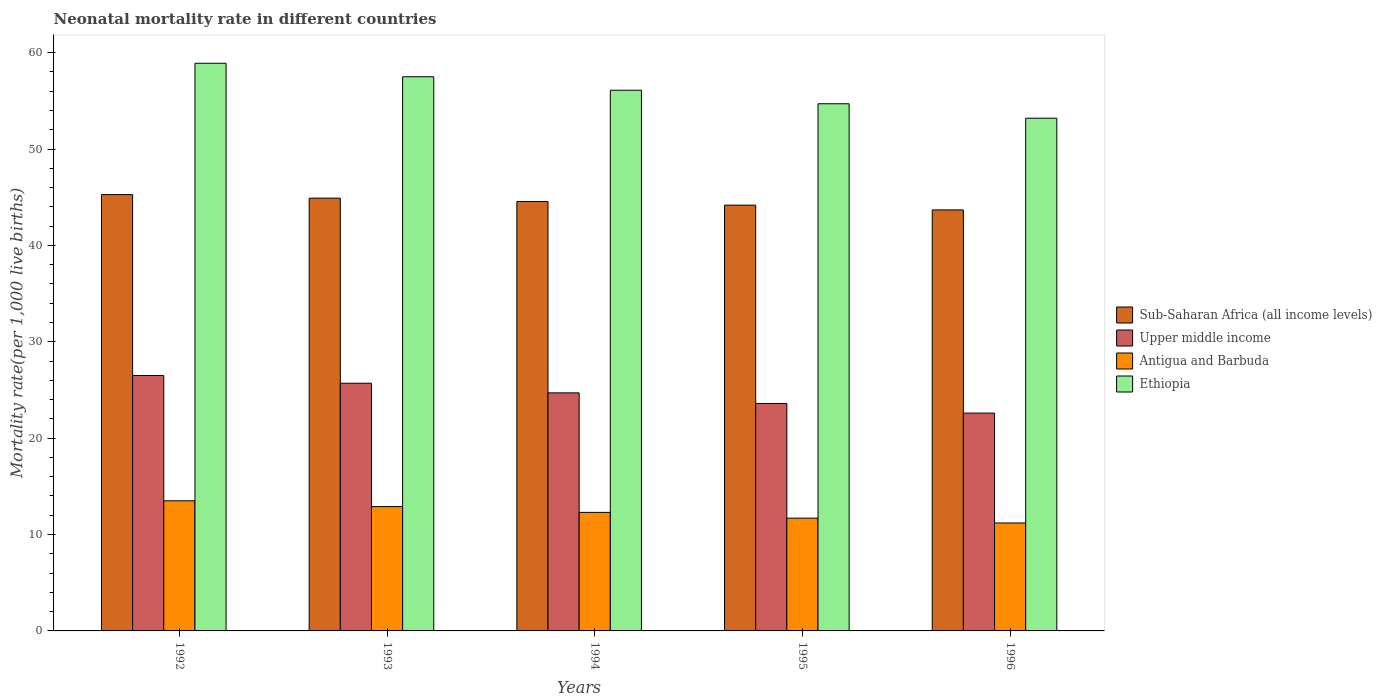How many bars are there on the 4th tick from the left?
Keep it short and to the point. 4. What is the label of the 2nd group of bars from the left?
Provide a short and direct response. 1993. Across all years, what is the maximum neonatal mortality rate in Antigua and Barbuda?
Ensure brevity in your answer.  13.5. In which year was the neonatal mortality rate in Sub-Saharan Africa (all income levels) minimum?
Provide a short and direct response. 1996. What is the total neonatal mortality rate in Upper middle income in the graph?
Offer a terse response. 123.1. What is the difference between the neonatal mortality rate in Ethiopia in 1993 and that in 1995?
Your answer should be very brief. 2.8. What is the difference between the neonatal mortality rate in Sub-Saharan Africa (all income levels) in 1996 and the neonatal mortality rate in Ethiopia in 1995?
Make the answer very short. -11.02. What is the average neonatal mortality rate in Antigua and Barbuda per year?
Make the answer very short. 12.32. In the year 1996, what is the difference between the neonatal mortality rate in Upper middle income and neonatal mortality rate in Sub-Saharan Africa (all income levels)?
Your answer should be compact. -21.08. What is the ratio of the neonatal mortality rate in Upper middle income in 1995 to that in 1996?
Provide a succinct answer. 1.04. Is the difference between the neonatal mortality rate in Upper middle income in 1994 and 1996 greater than the difference between the neonatal mortality rate in Sub-Saharan Africa (all income levels) in 1994 and 1996?
Your response must be concise. Yes. What is the difference between the highest and the second highest neonatal mortality rate in Ethiopia?
Make the answer very short. 1.4. What is the difference between the highest and the lowest neonatal mortality rate in Sub-Saharan Africa (all income levels)?
Keep it short and to the point. 1.59. In how many years, is the neonatal mortality rate in Antigua and Barbuda greater than the average neonatal mortality rate in Antigua and Barbuda taken over all years?
Your answer should be very brief. 2. Is it the case that in every year, the sum of the neonatal mortality rate in Upper middle income and neonatal mortality rate in Ethiopia is greater than the sum of neonatal mortality rate in Sub-Saharan Africa (all income levels) and neonatal mortality rate in Antigua and Barbuda?
Keep it short and to the point. No. What does the 1st bar from the left in 1993 represents?
Your response must be concise. Sub-Saharan Africa (all income levels). What does the 3rd bar from the right in 1992 represents?
Ensure brevity in your answer.  Upper middle income. Is it the case that in every year, the sum of the neonatal mortality rate in Antigua and Barbuda and neonatal mortality rate in Sub-Saharan Africa (all income levels) is greater than the neonatal mortality rate in Ethiopia?
Give a very brief answer. No. How many bars are there?
Ensure brevity in your answer.  20. Are all the bars in the graph horizontal?
Offer a terse response. No. What is the difference between two consecutive major ticks on the Y-axis?
Provide a short and direct response. 10. Are the values on the major ticks of Y-axis written in scientific E-notation?
Make the answer very short. No. Does the graph contain grids?
Provide a succinct answer. No. Where does the legend appear in the graph?
Keep it short and to the point. Center right. How are the legend labels stacked?
Your response must be concise. Vertical. What is the title of the graph?
Your response must be concise. Neonatal mortality rate in different countries. What is the label or title of the X-axis?
Keep it short and to the point. Years. What is the label or title of the Y-axis?
Provide a short and direct response. Mortality rate(per 1,0 live births). What is the Mortality rate(per 1,000 live births) in Sub-Saharan Africa (all income levels) in 1992?
Offer a very short reply. 45.27. What is the Mortality rate(per 1,000 live births) in Ethiopia in 1992?
Provide a succinct answer. 58.9. What is the Mortality rate(per 1,000 live births) of Sub-Saharan Africa (all income levels) in 1993?
Your answer should be very brief. 44.91. What is the Mortality rate(per 1,000 live births) in Upper middle income in 1993?
Ensure brevity in your answer.  25.7. What is the Mortality rate(per 1,000 live births) in Antigua and Barbuda in 1993?
Your answer should be compact. 12.9. What is the Mortality rate(per 1,000 live births) of Ethiopia in 1993?
Your answer should be compact. 57.5. What is the Mortality rate(per 1,000 live births) in Sub-Saharan Africa (all income levels) in 1994?
Make the answer very short. 44.55. What is the Mortality rate(per 1,000 live births) of Upper middle income in 1994?
Keep it short and to the point. 24.7. What is the Mortality rate(per 1,000 live births) of Antigua and Barbuda in 1994?
Ensure brevity in your answer.  12.3. What is the Mortality rate(per 1,000 live births) in Ethiopia in 1994?
Offer a very short reply. 56.1. What is the Mortality rate(per 1,000 live births) in Sub-Saharan Africa (all income levels) in 1995?
Your answer should be very brief. 44.18. What is the Mortality rate(per 1,000 live births) of Upper middle income in 1995?
Ensure brevity in your answer.  23.6. What is the Mortality rate(per 1,000 live births) of Antigua and Barbuda in 1995?
Ensure brevity in your answer.  11.7. What is the Mortality rate(per 1,000 live births) in Ethiopia in 1995?
Make the answer very short. 54.7. What is the Mortality rate(per 1,000 live births) in Sub-Saharan Africa (all income levels) in 1996?
Offer a terse response. 43.68. What is the Mortality rate(per 1,000 live births) in Upper middle income in 1996?
Offer a very short reply. 22.6. What is the Mortality rate(per 1,000 live births) of Antigua and Barbuda in 1996?
Offer a terse response. 11.2. What is the Mortality rate(per 1,000 live births) in Ethiopia in 1996?
Give a very brief answer. 53.2. Across all years, what is the maximum Mortality rate(per 1,000 live births) of Sub-Saharan Africa (all income levels)?
Your response must be concise. 45.27. Across all years, what is the maximum Mortality rate(per 1,000 live births) of Upper middle income?
Give a very brief answer. 26.5. Across all years, what is the maximum Mortality rate(per 1,000 live births) in Antigua and Barbuda?
Your answer should be compact. 13.5. Across all years, what is the maximum Mortality rate(per 1,000 live births) in Ethiopia?
Offer a terse response. 58.9. Across all years, what is the minimum Mortality rate(per 1,000 live births) of Sub-Saharan Africa (all income levels)?
Offer a very short reply. 43.68. Across all years, what is the minimum Mortality rate(per 1,000 live births) in Upper middle income?
Make the answer very short. 22.6. Across all years, what is the minimum Mortality rate(per 1,000 live births) in Ethiopia?
Give a very brief answer. 53.2. What is the total Mortality rate(per 1,000 live births) in Sub-Saharan Africa (all income levels) in the graph?
Offer a terse response. 222.59. What is the total Mortality rate(per 1,000 live births) in Upper middle income in the graph?
Offer a very short reply. 123.1. What is the total Mortality rate(per 1,000 live births) in Antigua and Barbuda in the graph?
Offer a very short reply. 61.6. What is the total Mortality rate(per 1,000 live births) of Ethiopia in the graph?
Your answer should be compact. 280.4. What is the difference between the Mortality rate(per 1,000 live births) in Sub-Saharan Africa (all income levels) in 1992 and that in 1993?
Give a very brief answer. 0.37. What is the difference between the Mortality rate(per 1,000 live births) of Upper middle income in 1992 and that in 1993?
Your response must be concise. 0.8. What is the difference between the Mortality rate(per 1,000 live births) in Antigua and Barbuda in 1992 and that in 1993?
Provide a short and direct response. 0.6. What is the difference between the Mortality rate(per 1,000 live births) of Ethiopia in 1992 and that in 1993?
Ensure brevity in your answer.  1.4. What is the difference between the Mortality rate(per 1,000 live births) in Sub-Saharan Africa (all income levels) in 1992 and that in 1994?
Make the answer very short. 0.72. What is the difference between the Mortality rate(per 1,000 live births) in Antigua and Barbuda in 1992 and that in 1994?
Provide a short and direct response. 1.2. What is the difference between the Mortality rate(per 1,000 live births) in Ethiopia in 1992 and that in 1994?
Your answer should be very brief. 2.8. What is the difference between the Mortality rate(per 1,000 live births) of Sub-Saharan Africa (all income levels) in 1992 and that in 1995?
Your answer should be very brief. 1.09. What is the difference between the Mortality rate(per 1,000 live births) of Upper middle income in 1992 and that in 1995?
Provide a succinct answer. 2.9. What is the difference between the Mortality rate(per 1,000 live births) of Antigua and Barbuda in 1992 and that in 1995?
Offer a very short reply. 1.8. What is the difference between the Mortality rate(per 1,000 live births) of Sub-Saharan Africa (all income levels) in 1992 and that in 1996?
Give a very brief answer. 1.59. What is the difference between the Mortality rate(per 1,000 live births) in Upper middle income in 1992 and that in 1996?
Provide a short and direct response. 3.9. What is the difference between the Mortality rate(per 1,000 live births) of Sub-Saharan Africa (all income levels) in 1993 and that in 1994?
Offer a terse response. 0.35. What is the difference between the Mortality rate(per 1,000 live births) in Upper middle income in 1993 and that in 1994?
Your answer should be compact. 1. What is the difference between the Mortality rate(per 1,000 live births) in Antigua and Barbuda in 1993 and that in 1994?
Make the answer very short. 0.6. What is the difference between the Mortality rate(per 1,000 live births) of Ethiopia in 1993 and that in 1994?
Offer a very short reply. 1.4. What is the difference between the Mortality rate(per 1,000 live births) in Sub-Saharan Africa (all income levels) in 1993 and that in 1995?
Offer a very short reply. 0.73. What is the difference between the Mortality rate(per 1,000 live births) in Upper middle income in 1993 and that in 1995?
Give a very brief answer. 2.1. What is the difference between the Mortality rate(per 1,000 live births) of Ethiopia in 1993 and that in 1995?
Give a very brief answer. 2.8. What is the difference between the Mortality rate(per 1,000 live births) of Sub-Saharan Africa (all income levels) in 1993 and that in 1996?
Your response must be concise. 1.22. What is the difference between the Mortality rate(per 1,000 live births) of Upper middle income in 1993 and that in 1996?
Make the answer very short. 3.1. What is the difference between the Mortality rate(per 1,000 live births) in Sub-Saharan Africa (all income levels) in 1994 and that in 1995?
Give a very brief answer. 0.37. What is the difference between the Mortality rate(per 1,000 live births) in Sub-Saharan Africa (all income levels) in 1994 and that in 1996?
Offer a very short reply. 0.87. What is the difference between the Mortality rate(per 1,000 live births) in Ethiopia in 1994 and that in 1996?
Keep it short and to the point. 2.9. What is the difference between the Mortality rate(per 1,000 live births) of Sub-Saharan Africa (all income levels) in 1995 and that in 1996?
Provide a short and direct response. 0.5. What is the difference between the Mortality rate(per 1,000 live births) of Upper middle income in 1995 and that in 1996?
Offer a very short reply. 1. What is the difference between the Mortality rate(per 1,000 live births) in Ethiopia in 1995 and that in 1996?
Keep it short and to the point. 1.5. What is the difference between the Mortality rate(per 1,000 live births) of Sub-Saharan Africa (all income levels) in 1992 and the Mortality rate(per 1,000 live births) of Upper middle income in 1993?
Provide a succinct answer. 19.57. What is the difference between the Mortality rate(per 1,000 live births) of Sub-Saharan Africa (all income levels) in 1992 and the Mortality rate(per 1,000 live births) of Antigua and Barbuda in 1993?
Provide a short and direct response. 32.37. What is the difference between the Mortality rate(per 1,000 live births) of Sub-Saharan Africa (all income levels) in 1992 and the Mortality rate(per 1,000 live births) of Ethiopia in 1993?
Ensure brevity in your answer.  -12.23. What is the difference between the Mortality rate(per 1,000 live births) in Upper middle income in 1992 and the Mortality rate(per 1,000 live births) in Ethiopia in 1993?
Your answer should be very brief. -31. What is the difference between the Mortality rate(per 1,000 live births) in Antigua and Barbuda in 1992 and the Mortality rate(per 1,000 live births) in Ethiopia in 1993?
Your answer should be compact. -44. What is the difference between the Mortality rate(per 1,000 live births) in Sub-Saharan Africa (all income levels) in 1992 and the Mortality rate(per 1,000 live births) in Upper middle income in 1994?
Keep it short and to the point. 20.57. What is the difference between the Mortality rate(per 1,000 live births) of Sub-Saharan Africa (all income levels) in 1992 and the Mortality rate(per 1,000 live births) of Antigua and Barbuda in 1994?
Offer a terse response. 32.97. What is the difference between the Mortality rate(per 1,000 live births) in Sub-Saharan Africa (all income levels) in 1992 and the Mortality rate(per 1,000 live births) in Ethiopia in 1994?
Keep it short and to the point. -10.83. What is the difference between the Mortality rate(per 1,000 live births) in Upper middle income in 1992 and the Mortality rate(per 1,000 live births) in Ethiopia in 1994?
Make the answer very short. -29.6. What is the difference between the Mortality rate(per 1,000 live births) of Antigua and Barbuda in 1992 and the Mortality rate(per 1,000 live births) of Ethiopia in 1994?
Make the answer very short. -42.6. What is the difference between the Mortality rate(per 1,000 live births) in Sub-Saharan Africa (all income levels) in 1992 and the Mortality rate(per 1,000 live births) in Upper middle income in 1995?
Ensure brevity in your answer.  21.67. What is the difference between the Mortality rate(per 1,000 live births) of Sub-Saharan Africa (all income levels) in 1992 and the Mortality rate(per 1,000 live births) of Antigua and Barbuda in 1995?
Provide a short and direct response. 33.57. What is the difference between the Mortality rate(per 1,000 live births) of Sub-Saharan Africa (all income levels) in 1992 and the Mortality rate(per 1,000 live births) of Ethiopia in 1995?
Ensure brevity in your answer.  -9.43. What is the difference between the Mortality rate(per 1,000 live births) in Upper middle income in 1992 and the Mortality rate(per 1,000 live births) in Ethiopia in 1995?
Your response must be concise. -28.2. What is the difference between the Mortality rate(per 1,000 live births) of Antigua and Barbuda in 1992 and the Mortality rate(per 1,000 live births) of Ethiopia in 1995?
Ensure brevity in your answer.  -41.2. What is the difference between the Mortality rate(per 1,000 live births) in Sub-Saharan Africa (all income levels) in 1992 and the Mortality rate(per 1,000 live births) in Upper middle income in 1996?
Make the answer very short. 22.67. What is the difference between the Mortality rate(per 1,000 live births) in Sub-Saharan Africa (all income levels) in 1992 and the Mortality rate(per 1,000 live births) in Antigua and Barbuda in 1996?
Keep it short and to the point. 34.07. What is the difference between the Mortality rate(per 1,000 live births) in Sub-Saharan Africa (all income levels) in 1992 and the Mortality rate(per 1,000 live births) in Ethiopia in 1996?
Offer a terse response. -7.93. What is the difference between the Mortality rate(per 1,000 live births) of Upper middle income in 1992 and the Mortality rate(per 1,000 live births) of Antigua and Barbuda in 1996?
Offer a very short reply. 15.3. What is the difference between the Mortality rate(per 1,000 live births) in Upper middle income in 1992 and the Mortality rate(per 1,000 live births) in Ethiopia in 1996?
Keep it short and to the point. -26.7. What is the difference between the Mortality rate(per 1,000 live births) in Antigua and Barbuda in 1992 and the Mortality rate(per 1,000 live births) in Ethiopia in 1996?
Provide a succinct answer. -39.7. What is the difference between the Mortality rate(per 1,000 live births) of Sub-Saharan Africa (all income levels) in 1993 and the Mortality rate(per 1,000 live births) of Upper middle income in 1994?
Provide a short and direct response. 20.21. What is the difference between the Mortality rate(per 1,000 live births) in Sub-Saharan Africa (all income levels) in 1993 and the Mortality rate(per 1,000 live births) in Antigua and Barbuda in 1994?
Give a very brief answer. 32.61. What is the difference between the Mortality rate(per 1,000 live births) of Sub-Saharan Africa (all income levels) in 1993 and the Mortality rate(per 1,000 live births) of Ethiopia in 1994?
Your answer should be very brief. -11.19. What is the difference between the Mortality rate(per 1,000 live births) in Upper middle income in 1993 and the Mortality rate(per 1,000 live births) in Ethiopia in 1994?
Provide a succinct answer. -30.4. What is the difference between the Mortality rate(per 1,000 live births) of Antigua and Barbuda in 1993 and the Mortality rate(per 1,000 live births) of Ethiopia in 1994?
Provide a short and direct response. -43.2. What is the difference between the Mortality rate(per 1,000 live births) of Sub-Saharan Africa (all income levels) in 1993 and the Mortality rate(per 1,000 live births) of Upper middle income in 1995?
Offer a very short reply. 21.31. What is the difference between the Mortality rate(per 1,000 live births) of Sub-Saharan Africa (all income levels) in 1993 and the Mortality rate(per 1,000 live births) of Antigua and Barbuda in 1995?
Give a very brief answer. 33.21. What is the difference between the Mortality rate(per 1,000 live births) of Sub-Saharan Africa (all income levels) in 1993 and the Mortality rate(per 1,000 live births) of Ethiopia in 1995?
Offer a terse response. -9.79. What is the difference between the Mortality rate(per 1,000 live births) of Upper middle income in 1993 and the Mortality rate(per 1,000 live births) of Antigua and Barbuda in 1995?
Ensure brevity in your answer.  14. What is the difference between the Mortality rate(per 1,000 live births) in Upper middle income in 1993 and the Mortality rate(per 1,000 live births) in Ethiopia in 1995?
Offer a very short reply. -29. What is the difference between the Mortality rate(per 1,000 live births) in Antigua and Barbuda in 1993 and the Mortality rate(per 1,000 live births) in Ethiopia in 1995?
Provide a short and direct response. -41.8. What is the difference between the Mortality rate(per 1,000 live births) in Sub-Saharan Africa (all income levels) in 1993 and the Mortality rate(per 1,000 live births) in Upper middle income in 1996?
Give a very brief answer. 22.31. What is the difference between the Mortality rate(per 1,000 live births) of Sub-Saharan Africa (all income levels) in 1993 and the Mortality rate(per 1,000 live births) of Antigua and Barbuda in 1996?
Your answer should be very brief. 33.71. What is the difference between the Mortality rate(per 1,000 live births) in Sub-Saharan Africa (all income levels) in 1993 and the Mortality rate(per 1,000 live births) in Ethiopia in 1996?
Provide a succinct answer. -8.29. What is the difference between the Mortality rate(per 1,000 live births) in Upper middle income in 1993 and the Mortality rate(per 1,000 live births) in Ethiopia in 1996?
Your answer should be compact. -27.5. What is the difference between the Mortality rate(per 1,000 live births) in Antigua and Barbuda in 1993 and the Mortality rate(per 1,000 live births) in Ethiopia in 1996?
Make the answer very short. -40.3. What is the difference between the Mortality rate(per 1,000 live births) of Sub-Saharan Africa (all income levels) in 1994 and the Mortality rate(per 1,000 live births) of Upper middle income in 1995?
Your answer should be compact. 20.95. What is the difference between the Mortality rate(per 1,000 live births) in Sub-Saharan Africa (all income levels) in 1994 and the Mortality rate(per 1,000 live births) in Antigua and Barbuda in 1995?
Offer a very short reply. 32.85. What is the difference between the Mortality rate(per 1,000 live births) of Sub-Saharan Africa (all income levels) in 1994 and the Mortality rate(per 1,000 live births) of Ethiopia in 1995?
Provide a succinct answer. -10.15. What is the difference between the Mortality rate(per 1,000 live births) of Antigua and Barbuda in 1994 and the Mortality rate(per 1,000 live births) of Ethiopia in 1995?
Offer a very short reply. -42.4. What is the difference between the Mortality rate(per 1,000 live births) in Sub-Saharan Africa (all income levels) in 1994 and the Mortality rate(per 1,000 live births) in Upper middle income in 1996?
Give a very brief answer. 21.95. What is the difference between the Mortality rate(per 1,000 live births) in Sub-Saharan Africa (all income levels) in 1994 and the Mortality rate(per 1,000 live births) in Antigua and Barbuda in 1996?
Your answer should be compact. 33.35. What is the difference between the Mortality rate(per 1,000 live births) of Sub-Saharan Africa (all income levels) in 1994 and the Mortality rate(per 1,000 live births) of Ethiopia in 1996?
Your answer should be compact. -8.65. What is the difference between the Mortality rate(per 1,000 live births) in Upper middle income in 1994 and the Mortality rate(per 1,000 live births) in Ethiopia in 1996?
Provide a succinct answer. -28.5. What is the difference between the Mortality rate(per 1,000 live births) of Antigua and Barbuda in 1994 and the Mortality rate(per 1,000 live births) of Ethiopia in 1996?
Your answer should be very brief. -40.9. What is the difference between the Mortality rate(per 1,000 live births) of Sub-Saharan Africa (all income levels) in 1995 and the Mortality rate(per 1,000 live births) of Upper middle income in 1996?
Give a very brief answer. 21.58. What is the difference between the Mortality rate(per 1,000 live births) of Sub-Saharan Africa (all income levels) in 1995 and the Mortality rate(per 1,000 live births) of Antigua and Barbuda in 1996?
Ensure brevity in your answer.  32.98. What is the difference between the Mortality rate(per 1,000 live births) in Sub-Saharan Africa (all income levels) in 1995 and the Mortality rate(per 1,000 live births) in Ethiopia in 1996?
Your answer should be very brief. -9.02. What is the difference between the Mortality rate(per 1,000 live births) of Upper middle income in 1995 and the Mortality rate(per 1,000 live births) of Ethiopia in 1996?
Give a very brief answer. -29.6. What is the difference between the Mortality rate(per 1,000 live births) in Antigua and Barbuda in 1995 and the Mortality rate(per 1,000 live births) in Ethiopia in 1996?
Keep it short and to the point. -41.5. What is the average Mortality rate(per 1,000 live births) of Sub-Saharan Africa (all income levels) per year?
Provide a short and direct response. 44.52. What is the average Mortality rate(per 1,000 live births) of Upper middle income per year?
Provide a short and direct response. 24.62. What is the average Mortality rate(per 1,000 live births) of Antigua and Barbuda per year?
Your answer should be compact. 12.32. What is the average Mortality rate(per 1,000 live births) in Ethiopia per year?
Your answer should be very brief. 56.08. In the year 1992, what is the difference between the Mortality rate(per 1,000 live births) in Sub-Saharan Africa (all income levels) and Mortality rate(per 1,000 live births) in Upper middle income?
Your answer should be compact. 18.77. In the year 1992, what is the difference between the Mortality rate(per 1,000 live births) of Sub-Saharan Africa (all income levels) and Mortality rate(per 1,000 live births) of Antigua and Barbuda?
Keep it short and to the point. 31.77. In the year 1992, what is the difference between the Mortality rate(per 1,000 live births) in Sub-Saharan Africa (all income levels) and Mortality rate(per 1,000 live births) in Ethiopia?
Give a very brief answer. -13.63. In the year 1992, what is the difference between the Mortality rate(per 1,000 live births) of Upper middle income and Mortality rate(per 1,000 live births) of Ethiopia?
Make the answer very short. -32.4. In the year 1992, what is the difference between the Mortality rate(per 1,000 live births) of Antigua and Barbuda and Mortality rate(per 1,000 live births) of Ethiopia?
Provide a succinct answer. -45.4. In the year 1993, what is the difference between the Mortality rate(per 1,000 live births) in Sub-Saharan Africa (all income levels) and Mortality rate(per 1,000 live births) in Upper middle income?
Your response must be concise. 19.21. In the year 1993, what is the difference between the Mortality rate(per 1,000 live births) of Sub-Saharan Africa (all income levels) and Mortality rate(per 1,000 live births) of Antigua and Barbuda?
Offer a terse response. 32.01. In the year 1993, what is the difference between the Mortality rate(per 1,000 live births) of Sub-Saharan Africa (all income levels) and Mortality rate(per 1,000 live births) of Ethiopia?
Ensure brevity in your answer.  -12.59. In the year 1993, what is the difference between the Mortality rate(per 1,000 live births) in Upper middle income and Mortality rate(per 1,000 live births) in Ethiopia?
Provide a short and direct response. -31.8. In the year 1993, what is the difference between the Mortality rate(per 1,000 live births) of Antigua and Barbuda and Mortality rate(per 1,000 live births) of Ethiopia?
Your answer should be very brief. -44.6. In the year 1994, what is the difference between the Mortality rate(per 1,000 live births) in Sub-Saharan Africa (all income levels) and Mortality rate(per 1,000 live births) in Upper middle income?
Offer a very short reply. 19.85. In the year 1994, what is the difference between the Mortality rate(per 1,000 live births) of Sub-Saharan Africa (all income levels) and Mortality rate(per 1,000 live births) of Antigua and Barbuda?
Your answer should be very brief. 32.25. In the year 1994, what is the difference between the Mortality rate(per 1,000 live births) of Sub-Saharan Africa (all income levels) and Mortality rate(per 1,000 live births) of Ethiopia?
Offer a very short reply. -11.55. In the year 1994, what is the difference between the Mortality rate(per 1,000 live births) in Upper middle income and Mortality rate(per 1,000 live births) in Antigua and Barbuda?
Ensure brevity in your answer.  12.4. In the year 1994, what is the difference between the Mortality rate(per 1,000 live births) in Upper middle income and Mortality rate(per 1,000 live births) in Ethiopia?
Provide a succinct answer. -31.4. In the year 1994, what is the difference between the Mortality rate(per 1,000 live births) in Antigua and Barbuda and Mortality rate(per 1,000 live births) in Ethiopia?
Ensure brevity in your answer.  -43.8. In the year 1995, what is the difference between the Mortality rate(per 1,000 live births) in Sub-Saharan Africa (all income levels) and Mortality rate(per 1,000 live births) in Upper middle income?
Your response must be concise. 20.58. In the year 1995, what is the difference between the Mortality rate(per 1,000 live births) in Sub-Saharan Africa (all income levels) and Mortality rate(per 1,000 live births) in Antigua and Barbuda?
Make the answer very short. 32.48. In the year 1995, what is the difference between the Mortality rate(per 1,000 live births) in Sub-Saharan Africa (all income levels) and Mortality rate(per 1,000 live births) in Ethiopia?
Provide a succinct answer. -10.52. In the year 1995, what is the difference between the Mortality rate(per 1,000 live births) of Upper middle income and Mortality rate(per 1,000 live births) of Antigua and Barbuda?
Give a very brief answer. 11.9. In the year 1995, what is the difference between the Mortality rate(per 1,000 live births) in Upper middle income and Mortality rate(per 1,000 live births) in Ethiopia?
Make the answer very short. -31.1. In the year 1995, what is the difference between the Mortality rate(per 1,000 live births) of Antigua and Barbuda and Mortality rate(per 1,000 live births) of Ethiopia?
Your answer should be compact. -43. In the year 1996, what is the difference between the Mortality rate(per 1,000 live births) of Sub-Saharan Africa (all income levels) and Mortality rate(per 1,000 live births) of Upper middle income?
Your answer should be very brief. 21.08. In the year 1996, what is the difference between the Mortality rate(per 1,000 live births) in Sub-Saharan Africa (all income levels) and Mortality rate(per 1,000 live births) in Antigua and Barbuda?
Ensure brevity in your answer.  32.48. In the year 1996, what is the difference between the Mortality rate(per 1,000 live births) in Sub-Saharan Africa (all income levels) and Mortality rate(per 1,000 live births) in Ethiopia?
Give a very brief answer. -9.52. In the year 1996, what is the difference between the Mortality rate(per 1,000 live births) in Upper middle income and Mortality rate(per 1,000 live births) in Antigua and Barbuda?
Give a very brief answer. 11.4. In the year 1996, what is the difference between the Mortality rate(per 1,000 live births) of Upper middle income and Mortality rate(per 1,000 live births) of Ethiopia?
Offer a very short reply. -30.6. In the year 1996, what is the difference between the Mortality rate(per 1,000 live births) of Antigua and Barbuda and Mortality rate(per 1,000 live births) of Ethiopia?
Provide a short and direct response. -42. What is the ratio of the Mortality rate(per 1,000 live births) of Upper middle income in 1992 to that in 1993?
Make the answer very short. 1.03. What is the ratio of the Mortality rate(per 1,000 live births) of Antigua and Barbuda in 1992 to that in 1993?
Offer a terse response. 1.05. What is the ratio of the Mortality rate(per 1,000 live births) of Ethiopia in 1992 to that in 1993?
Offer a terse response. 1.02. What is the ratio of the Mortality rate(per 1,000 live births) in Sub-Saharan Africa (all income levels) in 1992 to that in 1994?
Offer a very short reply. 1.02. What is the ratio of the Mortality rate(per 1,000 live births) of Upper middle income in 1992 to that in 1994?
Your answer should be compact. 1.07. What is the ratio of the Mortality rate(per 1,000 live births) of Antigua and Barbuda in 1992 to that in 1994?
Your response must be concise. 1.1. What is the ratio of the Mortality rate(per 1,000 live births) of Ethiopia in 1992 to that in 1994?
Offer a very short reply. 1.05. What is the ratio of the Mortality rate(per 1,000 live births) in Sub-Saharan Africa (all income levels) in 1992 to that in 1995?
Provide a succinct answer. 1.02. What is the ratio of the Mortality rate(per 1,000 live births) of Upper middle income in 1992 to that in 1995?
Offer a very short reply. 1.12. What is the ratio of the Mortality rate(per 1,000 live births) in Antigua and Barbuda in 1992 to that in 1995?
Give a very brief answer. 1.15. What is the ratio of the Mortality rate(per 1,000 live births) in Ethiopia in 1992 to that in 1995?
Ensure brevity in your answer.  1.08. What is the ratio of the Mortality rate(per 1,000 live births) of Sub-Saharan Africa (all income levels) in 1992 to that in 1996?
Your answer should be very brief. 1.04. What is the ratio of the Mortality rate(per 1,000 live births) of Upper middle income in 1992 to that in 1996?
Provide a succinct answer. 1.17. What is the ratio of the Mortality rate(per 1,000 live births) of Antigua and Barbuda in 1992 to that in 1996?
Offer a very short reply. 1.21. What is the ratio of the Mortality rate(per 1,000 live births) of Ethiopia in 1992 to that in 1996?
Offer a very short reply. 1.11. What is the ratio of the Mortality rate(per 1,000 live births) in Sub-Saharan Africa (all income levels) in 1993 to that in 1994?
Provide a short and direct response. 1.01. What is the ratio of the Mortality rate(per 1,000 live births) of Upper middle income in 1993 to that in 1994?
Your answer should be very brief. 1.04. What is the ratio of the Mortality rate(per 1,000 live births) in Antigua and Barbuda in 1993 to that in 1994?
Provide a short and direct response. 1.05. What is the ratio of the Mortality rate(per 1,000 live births) of Ethiopia in 1993 to that in 1994?
Your answer should be very brief. 1.02. What is the ratio of the Mortality rate(per 1,000 live births) in Sub-Saharan Africa (all income levels) in 1993 to that in 1995?
Offer a terse response. 1.02. What is the ratio of the Mortality rate(per 1,000 live births) of Upper middle income in 1993 to that in 1995?
Provide a short and direct response. 1.09. What is the ratio of the Mortality rate(per 1,000 live births) in Antigua and Barbuda in 1993 to that in 1995?
Ensure brevity in your answer.  1.1. What is the ratio of the Mortality rate(per 1,000 live births) of Ethiopia in 1993 to that in 1995?
Provide a succinct answer. 1.05. What is the ratio of the Mortality rate(per 1,000 live births) in Sub-Saharan Africa (all income levels) in 1993 to that in 1996?
Your answer should be very brief. 1.03. What is the ratio of the Mortality rate(per 1,000 live births) in Upper middle income in 1993 to that in 1996?
Keep it short and to the point. 1.14. What is the ratio of the Mortality rate(per 1,000 live births) of Antigua and Barbuda in 1993 to that in 1996?
Your answer should be compact. 1.15. What is the ratio of the Mortality rate(per 1,000 live births) in Ethiopia in 1993 to that in 1996?
Your answer should be compact. 1.08. What is the ratio of the Mortality rate(per 1,000 live births) of Sub-Saharan Africa (all income levels) in 1994 to that in 1995?
Give a very brief answer. 1.01. What is the ratio of the Mortality rate(per 1,000 live births) of Upper middle income in 1994 to that in 1995?
Give a very brief answer. 1.05. What is the ratio of the Mortality rate(per 1,000 live births) in Antigua and Barbuda in 1994 to that in 1995?
Provide a short and direct response. 1.05. What is the ratio of the Mortality rate(per 1,000 live births) in Ethiopia in 1994 to that in 1995?
Ensure brevity in your answer.  1.03. What is the ratio of the Mortality rate(per 1,000 live births) of Sub-Saharan Africa (all income levels) in 1994 to that in 1996?
Provide a short and direct response. 1.02. What is the ratio of the Mortality rate(per 1,000 live births) of Upper middle income in 1994 to that in 1996?
Provide a succinct answer. 1.09. What is the ratio of the Mortality rate(per 1,000 live births) in Antigua and Barbuda in 1994 to that in 1996?
Keep it short and to the point. 1.1. What is the ratio of the Mortality rate(per 1,000 live births) in Ethiopia in 1994 to that in 1996?
Your answer should be compact. 1.05. What is the ratio of the Mortality rate(per 1,000 live births) in Sub-Saharan Africa (all income levels) in 1995 to that in 1996?
Your response must be concise. 1.01. What is the ratio of the Mortality rate(per 1,000 live births) in Upper middle income in 1995 to that in 1996?
Keep it short and to the point. 1.04. What is the ratio of the Mortality rate(per 1,000 live births) in Antigua and Barbuda in 1995 to that in 1996?
Provide a succinct answer. 1.04. What is the ratio of the Mortality rate(per 1,000 live births) in Ethiopia in 1995 to that in 1996?
Ensure brevity in your answer.  1.03. What is the difference between the highest and the second highest Mortality rate(per 1,000 live births) of Sub-Saharan Africa (all income levels)?
Your answer should be very brief. 0.37. What is the difference between the highest and the second highest Mortality rate(per 1,000 live births) in Upper middle income?
Provide a succinct answer. 0.8. What is the difference between the highest and the second highest Mortality rate(per 1,000 live births) in Ethiopia?
Give a very brief answer. 1.4. What is the difference between the highest and the lowest Mortality rate(per 1,000 live births) in Sub-Saharan Africa (all income levels)?
Give a very brief answer. 1.59. What is the difference between the highest and the lowest Mortality rate(per 1,000 live births) in Ethiopia?
Your answer should be compact. 5.7. 